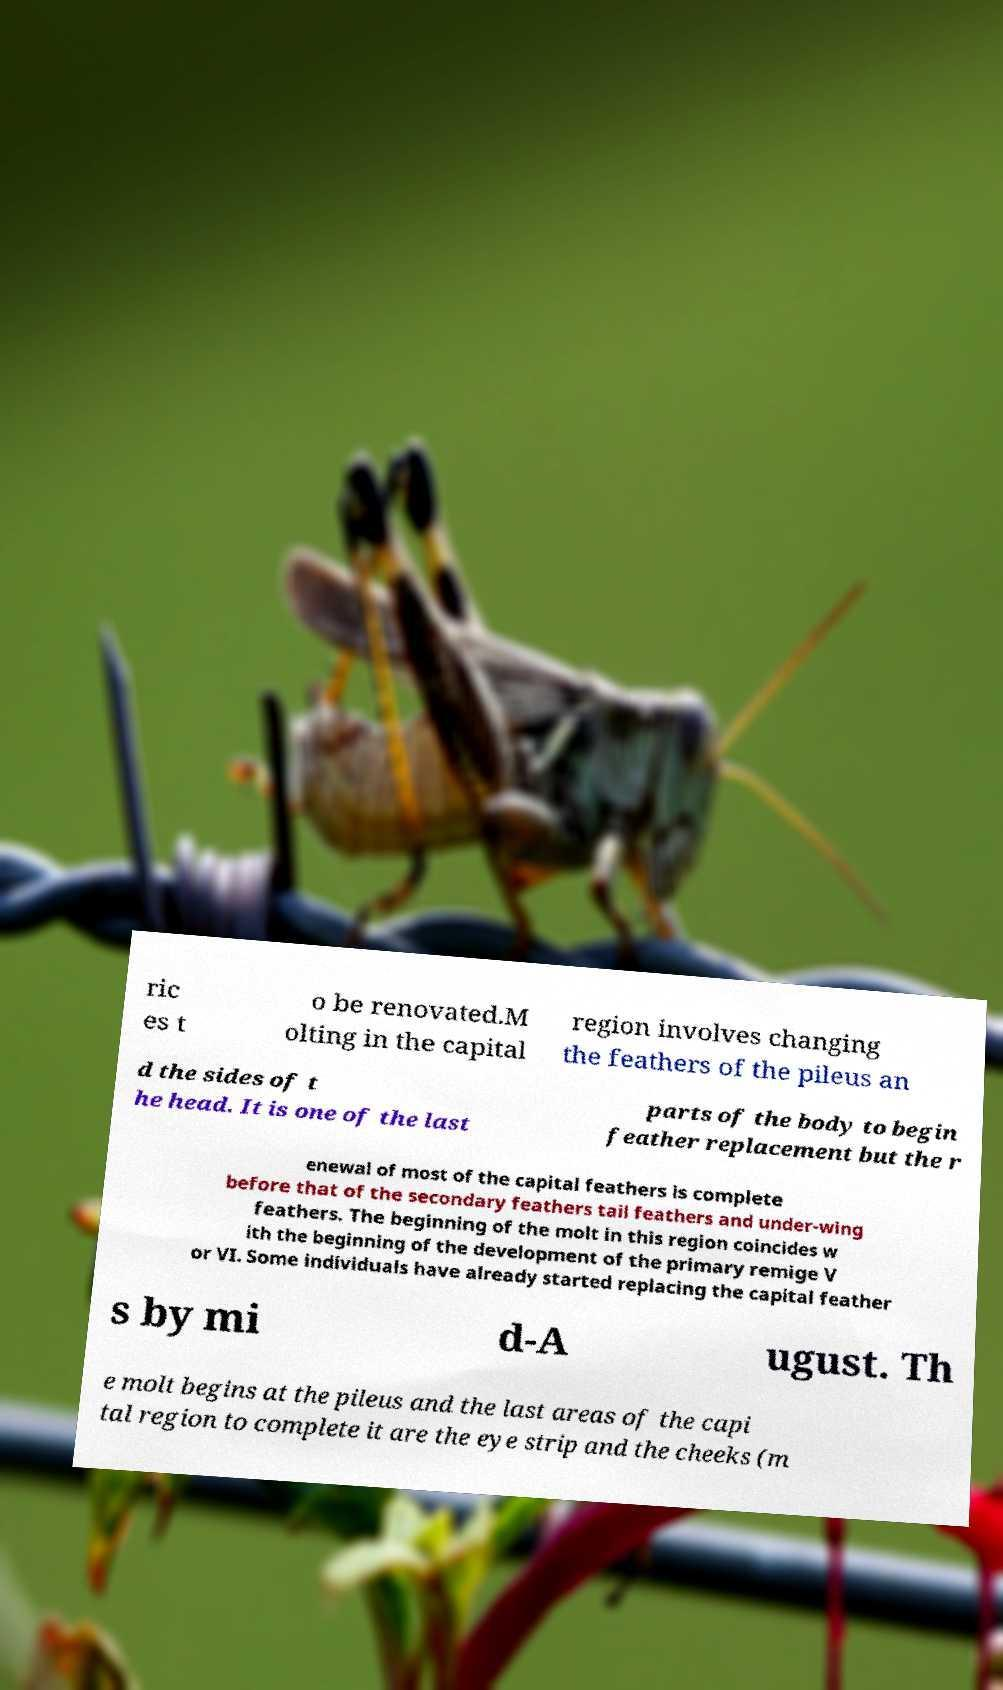There's text embedded in this image that I need extracted. Can you transcribe it verbatim? ric es t o be renovated.M olting in the capital region involves changing the feathers of the pileus an d the sides of t he head. It is one of the last parts of the body to begin feather replacement but the r enewal of most of the capital feathers is complete before that of the secondary feathers tail feathers and under-wing feathers. The beginning of the molt in this region coincides w ith the beginning of the development of the primary remige V or VI. Some individuals have already started replacing the capital feather s by mi d-A ugust. Th e molt begins at the pileus and the last areas of the capi tal region to complete it are the eye strip and the cheeks (m 